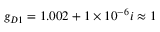<formula> <loc_0><loc_0><loc_500><loc_500>g _ { D 1 } = 1 . 0 0 2 + 1 \times 1 0 ^ { - 6 } i \approx 1</formula> 